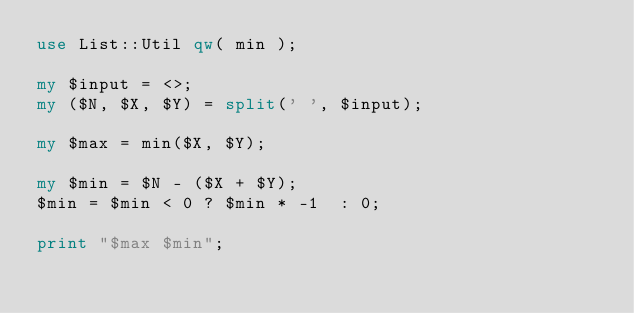<code> <loc_0><loc_0><loc_500><loc_500><_Perl_>use List::Util qw( min );

my $input = <>;
my ($N, $X, $Y) = split(' ', $input);

my $max = min($X, $Y);

my $min = $N - ($X + $Y);
$min = $min < 0 ? $min * -1  : 0;

print "$max $min";</code> 